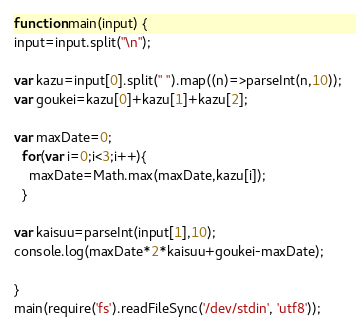<code> <loc_0><loc_0><loc_500><loc_500><_JavaScript_>function main(input) {
input=input.split("\n");
  
var kazu=input[0].split(" ").map((n)=>parseInt(n,10));
var goukei=kazu[0]+kazu[1]+kazu[2];
  
var maxDate=0;
  for(var i=0;i<3;i++){
    maxDate=Math.max(maxDate,kazu[i]);
  }

var kaisuu=parseInt(input[1],10);
console.log(maxDate*2*kaisuu+goukei-maxDate);

}
main(require('fs').readFileSync('/dev/stdin', 'utf8'));
</code> 